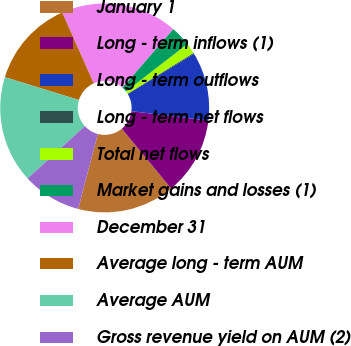<chart> <loc_0><loc_0><loc_500><loc_500><pie_chart><fcel>January 1<fcel>Long - term inflows (1)<fcel>Long - term outflows<fcel>Long - term net flows<fcel>Total net flows<fcel>Market gains and losses (1)<fcel>December 31<fcel>Average long - term AUM<fcel>Average AUM<fcel>Gross revenue yield on AUM (2)<nl><fcel>15.07%<fcel>12.09%<fcel>10.6%<fcel>0.16%<fcel>1.65%<fcel>3.14%<fcel>18.05%<fcel>13.58%<fcel>16.56%<fcel>9.11%<nl></chart> 